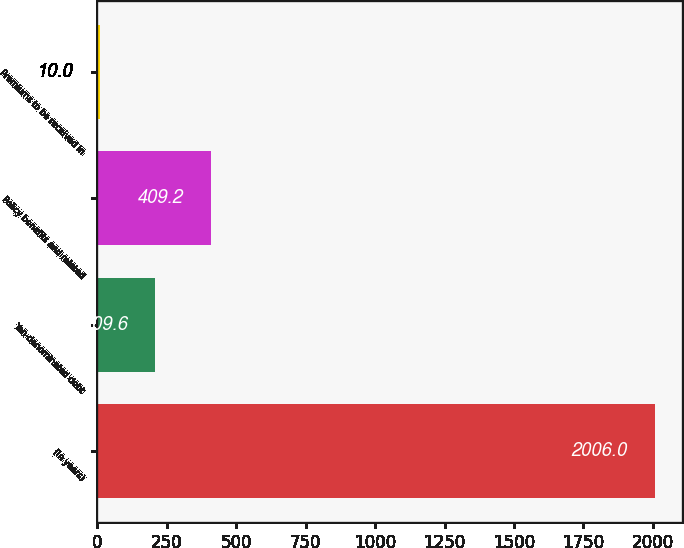Convert chart. <chart><loc_0><loc_0><loc_500><loc_500><bar_chart><fcel>(In years)<fcel>Yen-denominated debt<fcel>Policy benefits and related<fcel>Premiums to be received in<nl><fcel>2006<fcel>209.6<fcel>409.2<fcel>10<nl></chart> 